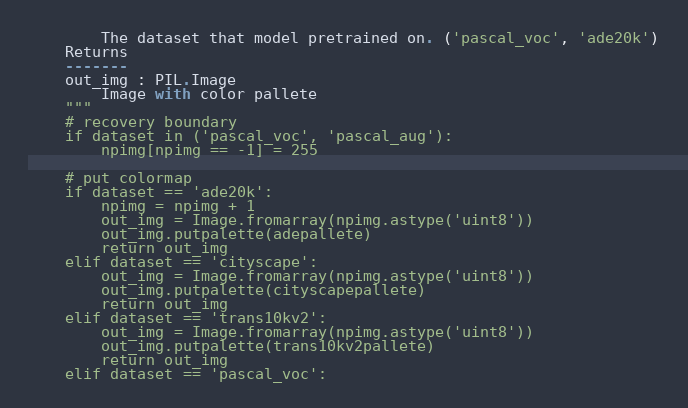Convert code to text. <code><loc_0><loc_0><loc_500><loc_500><_Python_>        The dataset that model pretrained on. ('pascal_voc', 'ade20k')
    Returns
    -------
    out_img : PIL.Image
        Image with color pallete
    """
    # recovery boundary
    if dataset in ('pascal_voc', 'pascal_aug'):
        npimg[npimg == -1] = 255

    # put colormap
    if dataset == 'ade20k':
        npimg = npimg + 1
        out_img = Image.fromarray(npimg.astype('uint8'))
        out_img.putpalette(adepallete)
        return out_img
    elif dataset == 'cityscape':
        out_img = Image.fromarray(npimg.astype('uint8'))
        out_img.putpalette(cityscapepallete)
        return out_img
    elif dataset == 'trans10kv2':
        out_img = Image.fromarray(npimg.astype('uint8'))
        out_img.putpalette(trans10kv2pallete)
        return out_img
    elif dataset == 'pascal_voc':</code> 